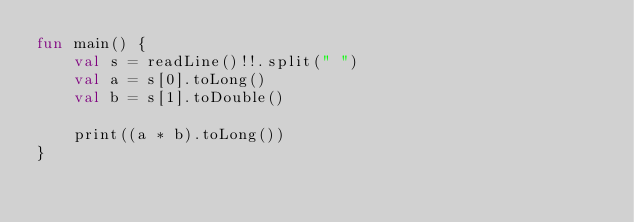<code> <loc_0><loc_0><loc_500><loc_500><_Kotlin_>fun main() {
    val s = readLine()!!.split(" ")
    val a = s[0].toLong()
    val b = s[1].toDouble()

    print((a * b).toLong())
}
</code> 